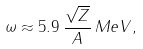<formula> <loc_0><loc_0><loc_500><loc_500>\omega \approx 5 . 9 \, \frac { \sqrt { Z } } { A } \, M e V ,</formula> 